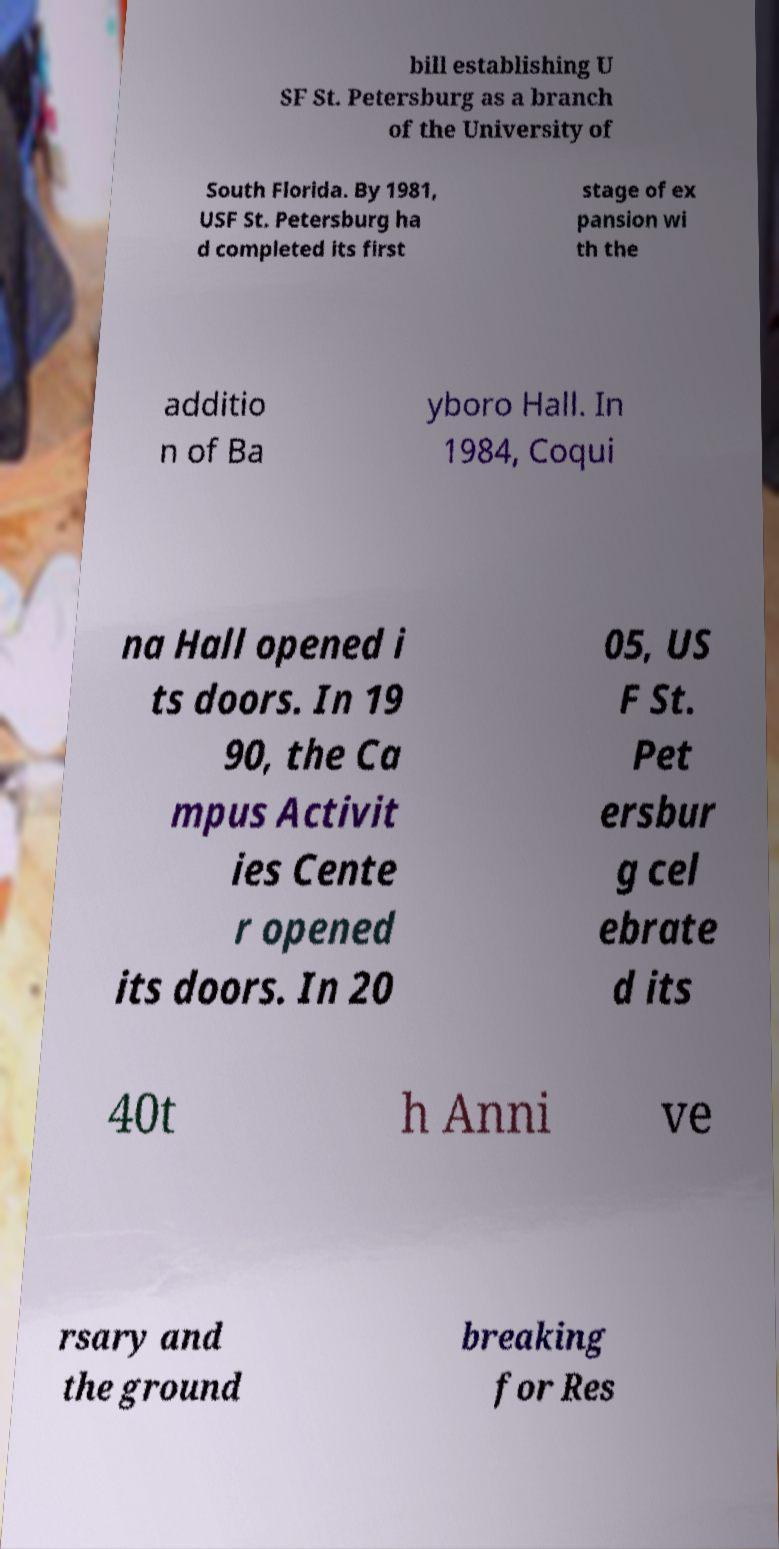Please read and relay the text visible in this image. What does it say? bill establishing U SF St. Petersburg as a branch of the University of South Florida. By 1981, USF St. Petersburg ha d completed its first stage of ex pansion wi th the additio n of Ba yboro Hall. In 1984, Coqui na Hall opened i ts doors. In 19 90, the Ca mpus Activit ies Cente r opened its doors. In 20 05, US F St. Pet ersbur g cel ebrate d its 40t h Anni ve rsary and the ground breaking for Res 